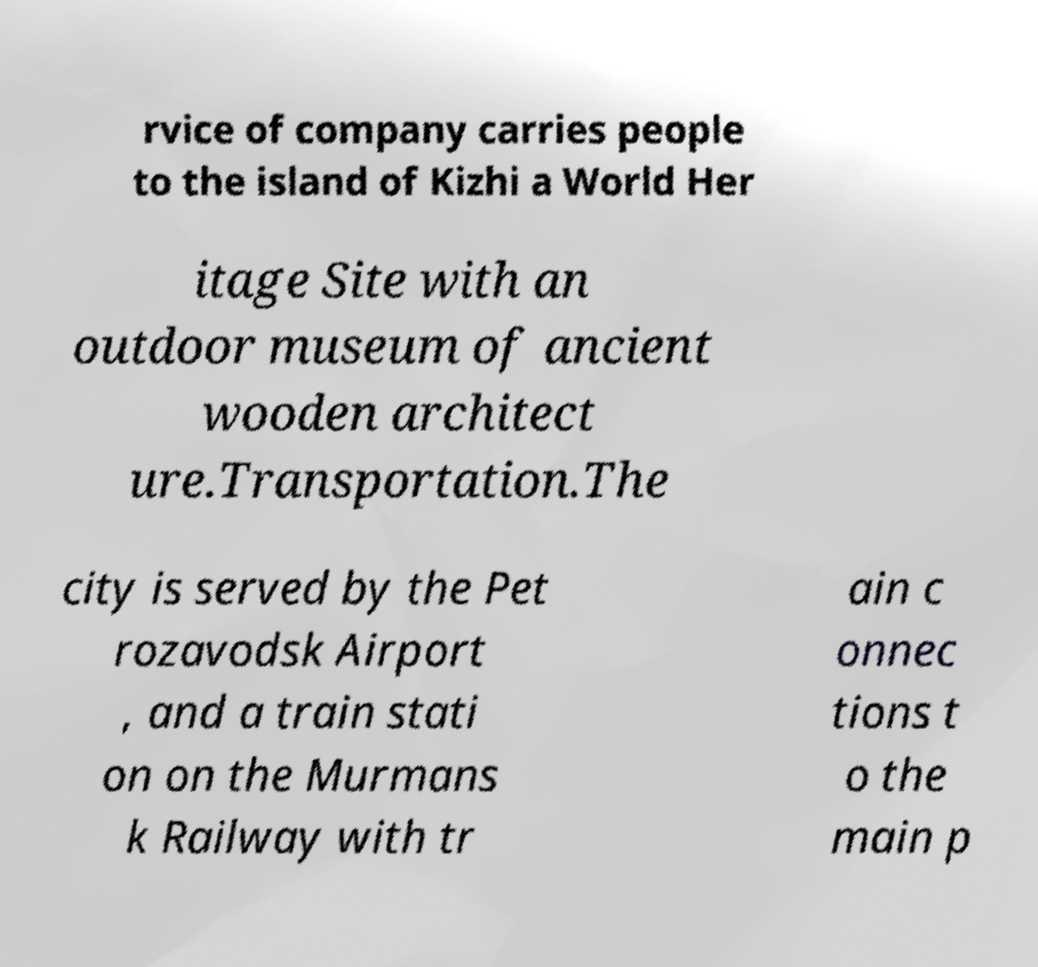Could you extract and type out the text from this image? rvice of company carries people to the island of Kizhi a World Her itage Site with an outdoor museum of ancient wooden architect ure.Transportation.The city is served by the Pet rozavodsk Airport , and a train stati on on the Murmans k Railway with tr ain c onnec tions t o the main p 